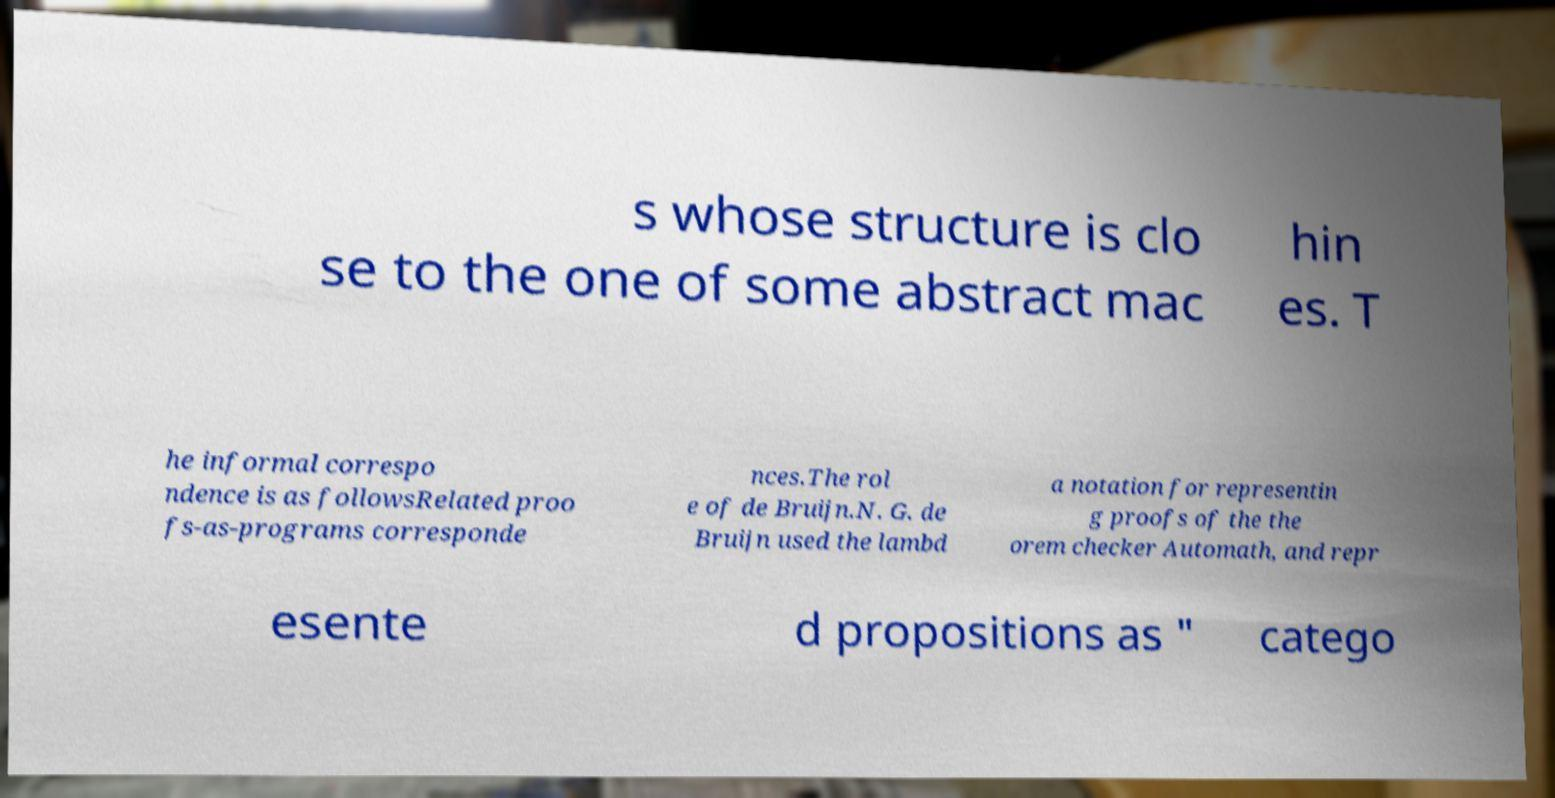Can you read and provide the text displayed in the image?This photo seems to have some interesting text. Can you extract and type it out for me? s whose structure is clo se to the one of some abstract mac hin es. T he informal correspo ndence is as followsRelated proo fs-as-programs corresponde nces.The rol e of de Bruijn.N. G. de Bruijn used the lambd a notation for representin g proofs of the the orem checker Automath, and repr esente d propositions as " catego 